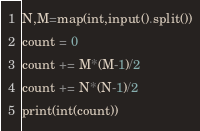<code> <loc_0><loc_0><loc_500><loc_500><_Python_>N,M=map(int,input().split())
count = 0
count += M*(M-1)/2
count += N*(N-1)/2
print(int(count))
</code> 